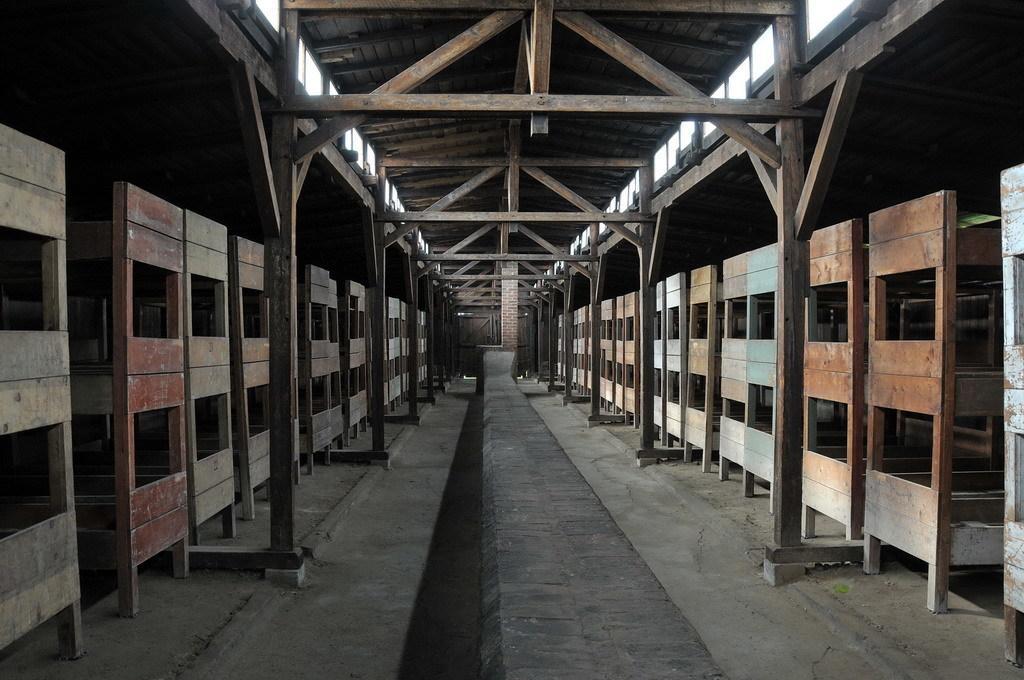How would you summarize this image in a sentence or two? In the image there are many wooden objects and above them there is a wooden roof, under the roof there are wooden poles. 